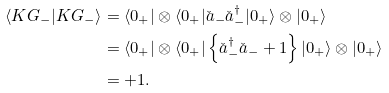Convert formula to latex. <formula><loc_0><loc_0><loc_500><loc_500>\langle K G _ { - } | K G _ { - } \rangle & = \langle 0 _ { + } | \otimes \langle 0 _ { + } | \check { a } _ { - } \check { a } _ { - } ^ { \dagger } | 0 _ { + } \rangle \otimes | 0 _ { + } \rangle \\ & = \langle 0 _ { + } | \otimes \langle 0 _ { + } | \left \{ \check { a } _ { - } ^ { \dagger } \check { a } _ { - } + 1 \right \} | 0 _ { + } \rangle \otimes | 0 _ { + } \rangle \\ & = + 1 .</formula> 